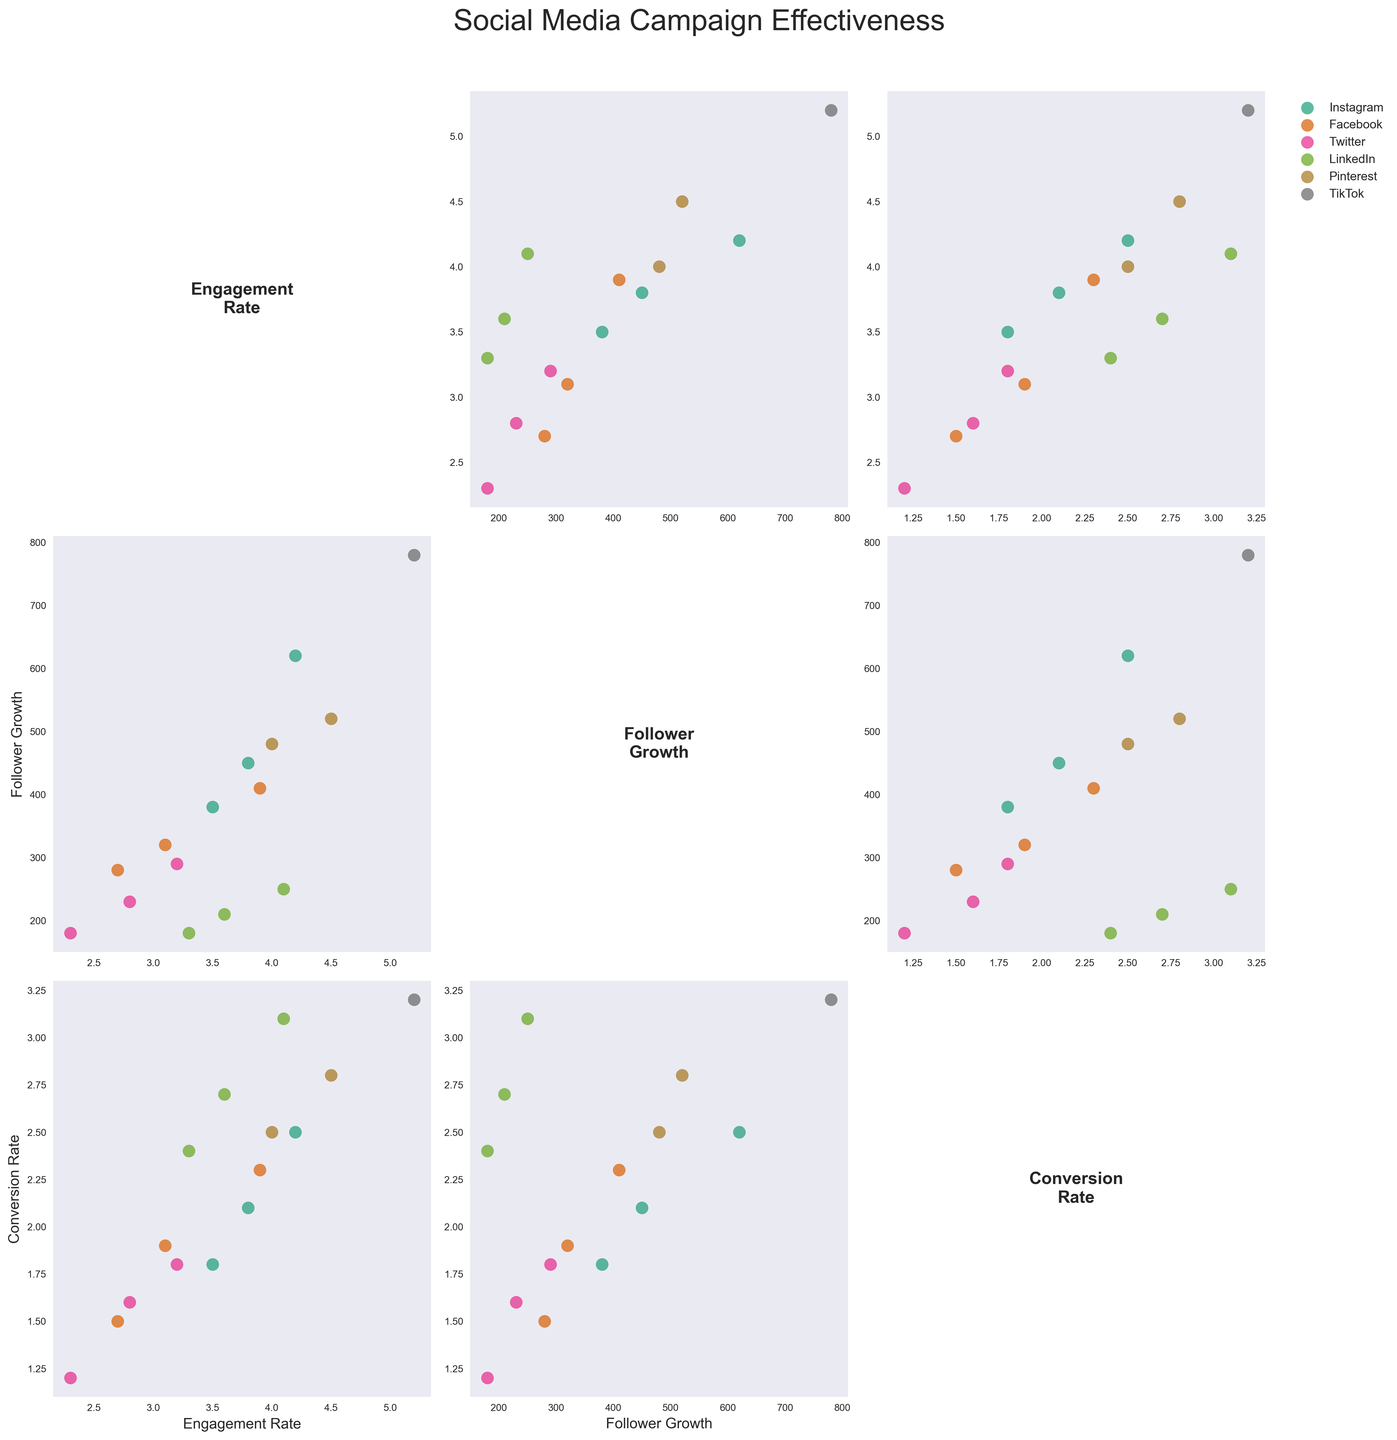Which platform shows the highest engagement rate? By observing the scatter plots, TikTok shows the highest engagement rate with a value of 5.2.
Answer: TikTok Which content type on Instagram has the most follower growth? In the scatter plot matrix, locate Instagram data points and compare follower growth for each content type. Video content has the highest follower growth of 620.
Answer: Video Compare the average conversion rate between Facebook and Twitter. Which platform has a higher average? Calculate the average for both platforms by summing their conversion rates and dividing by the number of data points. Facebook (1.5 + 1.9 + 2.3)/3 = 1.9, and Twitter (1.2 + 1.6 + 1.8)/3 = 1.53. Therefore, Facebook has a higher average conversion rate.
Answer: Facebook Are there any overlapping data points in the scatter plots for Engagement Rate and Follower Growth? Check the specific scatter plot comparing Engagement Rate vs. Follower Growth across all platforms for any data points that share the same coordinates. There don't appear to be any overlapping points in the plot.
Answer: No Which platform has the highest conversion rate? Look at the scatter plots showing conversion rates for all platforms. LinkedIn has the highest conversion rate of 3.1.
Answer: LinkedIn How many platforms show a conversion rate higher than 2.5? Count the platforms with conversion rates above 2.5 in the relevant scatter plots. Platforms with higher conversion rates than 2.5 include LinkedIn and TikTok (2 platforms).
Answer: 2 Compare the follower growth trend between Pinterest and LinkedIn. Which has a more consistent trend? By observing the scatter plots for Follower Growth, Pinterest shows more variation (520, 480) compared to LinkedIn’s narrower range (210, 180, 250). LinkedIn follows a more consistent trend.
Answer: LinkedIn Is there a positive correlation between Engagement Rate and Conversion Rate across platforms? Look at the scatter plots comparing Engagement Rate vs. Conversion Rate. Most platforms have higher conversion rates with higher engagement rates, indicating a positive correlation.
Answer: Yes Which platform shows the least engagement rate? From the scatter plots showing Engagement Rate for all platforms, Twitter has the lowest engagement rate with a value of 2.3.
Answer: Twitter 